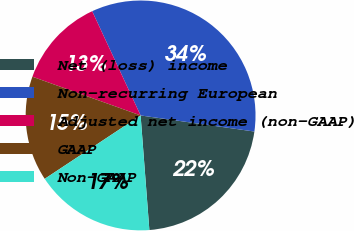Convert chart. <chart><loc_0><loc_0><loc_500><loc_500><pie_chart><fcel>Net (loss) income<fcel>Non-recurring European<fcel>Adjusted net income (non-GAAP)<fcel>GAAP<fcel>Non-GAAP<nl><fcel>21.55%<fcel>34.16%<fcel>12.61%<fcel>14.77%<fcel>16.92%<nl></chart> 